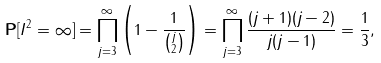Convert formula to latex. <formula><loc_0><loc_0><loc_500><loc_500>\mathbf P [ I ^ { 2 } = \infty ] & = \prod _ { j = 3 } ^ { \infty } \left ( 1 - \frac { 1 } { \binom { j } { 2 } } \right ) = \prod _ { j = 3 } ^ { \infty } \frac { ( j + 1 ) ( j - 2 ) } { j ( j - 1 ) } = \frac { 1 } { 3 } ,</formula> 